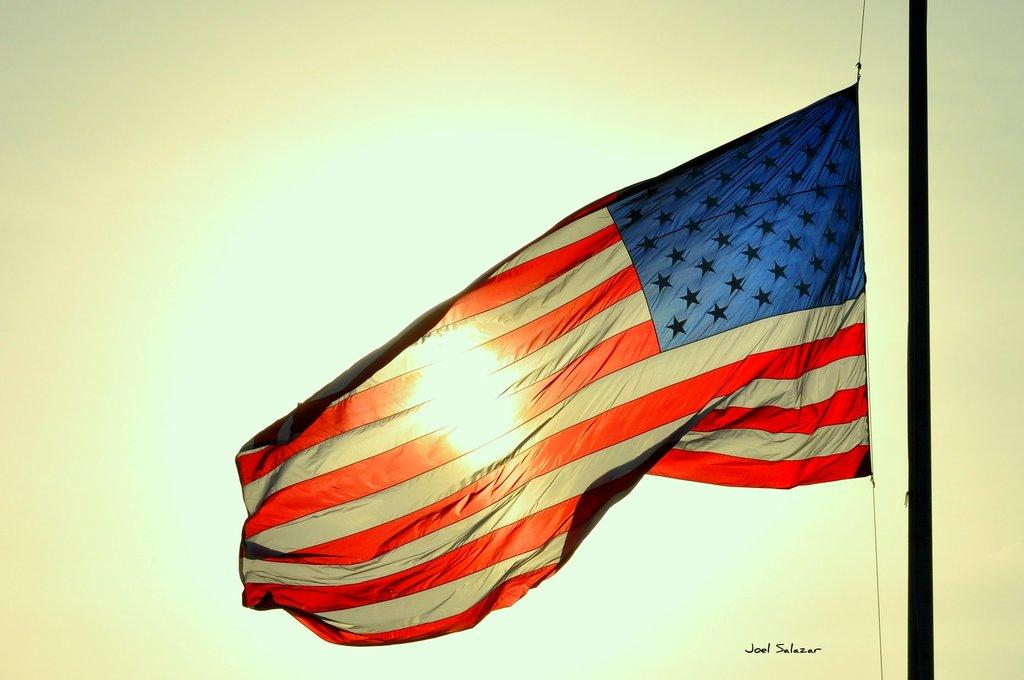What is the main object in the image? There is a flag in the image. What is the flag attached to? The flag is attached to a pole in the image. Is there any text visible in the image? Yes, there is some text visible in the bottom right of the image. Can you see any goats in the wilderness in the image? There is no wilderness or goats present in the image; it features a flag and a pole. 